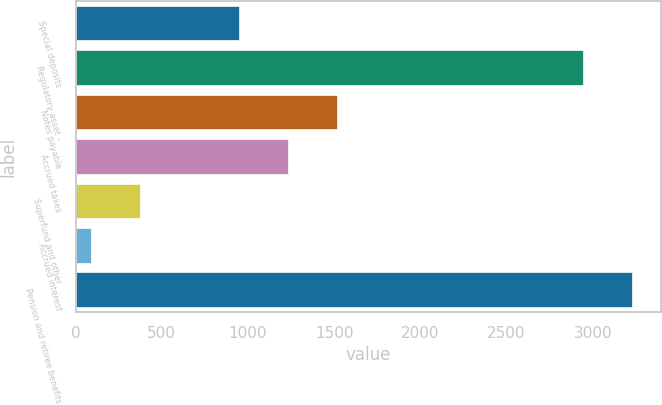<chart> <loc_0><loc_0><loc_500><loc_500><bar_chart><fcel>Special deposits<fcel>Regulatory asset -<fcel>Notes payable<fcel>Accrued taxes<fcel>Superfund and other<fcel>Accrued interest<fcel>Pension and retiree benefits<nl><fcel>952.5<fcel>2947<fcel>1523.5<fcel>1238<fcel>381.5<fcel>96<fcel>3232.5<nl></chart> 